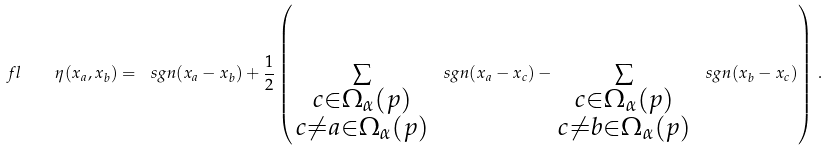Convert formula to latex. <formula><loc_0><loc_0><loc_500><loc_500>\ f l \quad \eta ( x _ { a } , x _ { b } ) = \ s g n ( x _ { a } - x _ { b } ) + \frac { 1 } { 2 } \left ( \, \sum _ { \substack { c \in \Omega _ { \alpha } ( p ) \\ c \neq a \in \Omega _ { \alpha } ( p ) } } \, \ s g n ( x _ { a } - x _ { c } ) - \, \sum _ { \substack { c \in \Omega _ { \alpha } ( p ) \\ c \neq b \in \Omega _ { \alpha } ( p ) } } \, \ s g n ( x _ { b } - x _ { c } ) \right ) \, .</formula> 